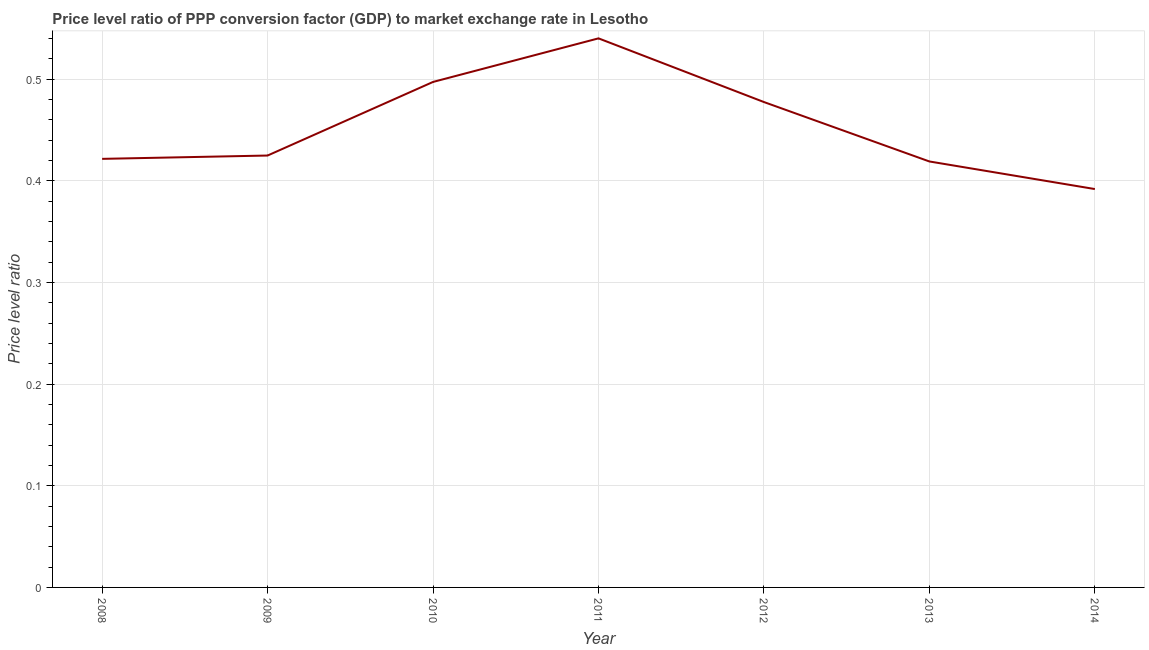What is the price level ratio in 2012?
Make the answer very short. 0.48. Across all years, what is the maximum price level ratio?
Offer a terse response. 0.54. Across all years, what is the minimum price level ratio?
Offer a very short reply. 0.39. In which year was the price level ratio maximum?
Give a very brief answer. 2011. In which year was the price level ratio minimum?
Give a very brief answer. 2014. What is the sum of the price level ratio?
Offer a terse response. 3.17. What is the difference between the price level ratio in 2008 and 2012?
Make the answer very short. -0.06. What is the average price level ratio per year?
Offer a terse response. 0.45. What is the median price level ratio?
Offer a very short reply. 0.42. What is the ratio of the price level ratio in 2010 to that in 2014?
Offer a terse response. 1.27. What is the difference between the highest and the second highest price level ratio?
Your answer should be compact. 0.04. Is the sum of the price level ratio in 2009 and 2010 greater than the maximum price level ratio across all years?
Provide a succinct answer. Yes. What is the difference between the highest and the lowest price level ratio?
Your answer should be very brief. 0.15. In how many years, is the price level ratio greater than the average price level ratio taken over all years?
Keep it short and to the point. 3. What is the difference between two consecutive major ticks on the Y-axis?
Offer a terse response. 0.1. Does the graph contain grids?
Your answer should be very brief. Yes. What is the title of the graph?
Provide a succinct answer. Price level ratio of PPP conversion factor (GDP) to market exchange rate in Lesotho. What is the label or title of the X-axis?
Offer a terse response. Year. What is the label or title of the Y-axis?
Your response must be concise. Price level ratio. What is the Price level ratio of 2008?
Make the answer very short. 0.42. What is the Price level ratio of 2009?
Provide a succinct answer. 0.42. What is the Price level ratio in 2010?
Offer a terse response. 0.5. What is the Price level ratio in 2011?
Your response must be concise. 0.54. What is the Price level ratio of 2012?
Give a very brief answer. 0.48. What is the Price level ratio in 2013?
Keep it short and to the point. 0.42. What is the Price level ratio in 2014?
Provide a short and direct response. 0.39. What is the difference between the Price level ratio in 2008 and 2009?
Provide a short and direct response. -0. What is the difference between the Price level ratio in 2008 and 2010?
Your response must be concise. -0.08. What is the difference between the Price level ratio in 2008 and 2011?
Give a very brief answer. -0.12. What is the difference between the Price level ratio in 2008 and 2012?
Your answer should be compact. -0.06. What is the difference between the Price level ratio in 2008 and 2013?
Ensure brevity in your answer.  0. What is the difference between the Price level ratio in 2008 and 2014?
Ensure brevity in your answer.  0.03. What is the difference between the Price level ratio in 2009 and 2010?
Provide a short and direct response. -0.07. What is the difference between the Price level ratio in 2009 and 2011?
Give a very brief answer. -0.12. What is the difference between the Price level ratio in 2009 and 2012?
Your response must be concise. -0.05. What is the difference between the Price level ratio in 2009 and 2013?
Keep it short and to the point. 0.01. What is the difference between the Price level ratio in 2009 and 2014?
Your answer should be very brief. 0.03. What is the difference between the Price level ratio in 2010 and 2011?
Make the answer very short. -0.04. What is the difference between the Price level ratio in 2010 and 2012?
Your answer should be compact. 0.02. What is the difference between the Price level ratio in 2010 and 2013?
Offer a very short reply. 0.08. What is the difference between the Price level ratio in 2010 and 2014?
Ensure brevity in your answer.  0.11. What is the difference between the Price level ratio in 2011 and 2012?
Give a very brief answer. 0.06. What is the difference between the Price level ratio in 2011 and 2013?
Ensure brevity in your answer.  0.12. What is the difference between the Price level ratio in 2011 and 2014?
Make the answer very short. 0.15. What is the difference between the Price level ratio in 2012 and 2013?
Your answer should be very brief. 0.06. What is the difference between the Price level ratio in 2012 and 2014?
Your answer should be compact. 0.09. What is the difference between the Price level ratio in 2013 and 2014?
Make the answer very short. 0.03. What is the ratio of the Price level ratio in 2008 to that in 2010?
Provide a short and direct response. 0.85. What is the ratio of the Price level ratio in 2008 to that in 2011?
Offer a terse response. 0.78. What is the ratio of the Price level ratio in 2008 to that in 2012?
Ensure brevity in your answer.  0.88. What is the ratio of the Price level ratio in 2008 to that in 2013?
Keep it short and to the point. 1.01. What is the ratio of the Price level ratio in 2008 to that in 2014?
Offer a terse response. 1.08. What is the ratio of the Price level ratio in 2009 to that in 2010?
Provide a succinct answer. 0.85. What is the ratio of the Price level ratio in 2009 to that in 2011?
Offer a very short reply. 0.79. What is the ratio of the Price level ratio in 2009 to that in 2012?
Your answer should be very brief. 0.89. What is the ratio of the Price level ratio in 2009 to that in 2013?
Ensure brevity in your answer.  1.01. What is the ratio of the Price level ratio in 2009 to that in 2014?
Offer a very short reply. 1.08. What is the ratio of the Price level ratio in 2010 to that in 2011?
Your response must be concise. 0.92. What is the ratio of the Price level ratio in 2010 to that in 2012?
Give a very brief answer. 1.04. What is the ratio of the Price level ratio in 2010 to that in 2013?
Make the answer very short. 1.19. What is the ratio of the Price level ratio in 2010 to that in 2014?
Your response must be concise. 1.27. What is the ratio of the Price level ratio in 2011 to that in 2012?
Your answer should be compact. 1.13. What is the ratio of the Price level ratio in 2011 to that in 2013?
Make the answer very short. 1.29. What is the ratio of the Price level ratio in 2011 to that in 2014?
Ensure brevity in your answer.  1.38. What is the ratio of the Price level ratio in 2012 to that in 2013?
Keep it short and to the point. 1.14. What is the ratio of the Price level ratio in 2012 to that in 2014?
Offer a terse response. 1.22. What is the ratio of the Price level ratio in 2013 to that in 2014?
Ensure brevity in your answer.  1.07. 